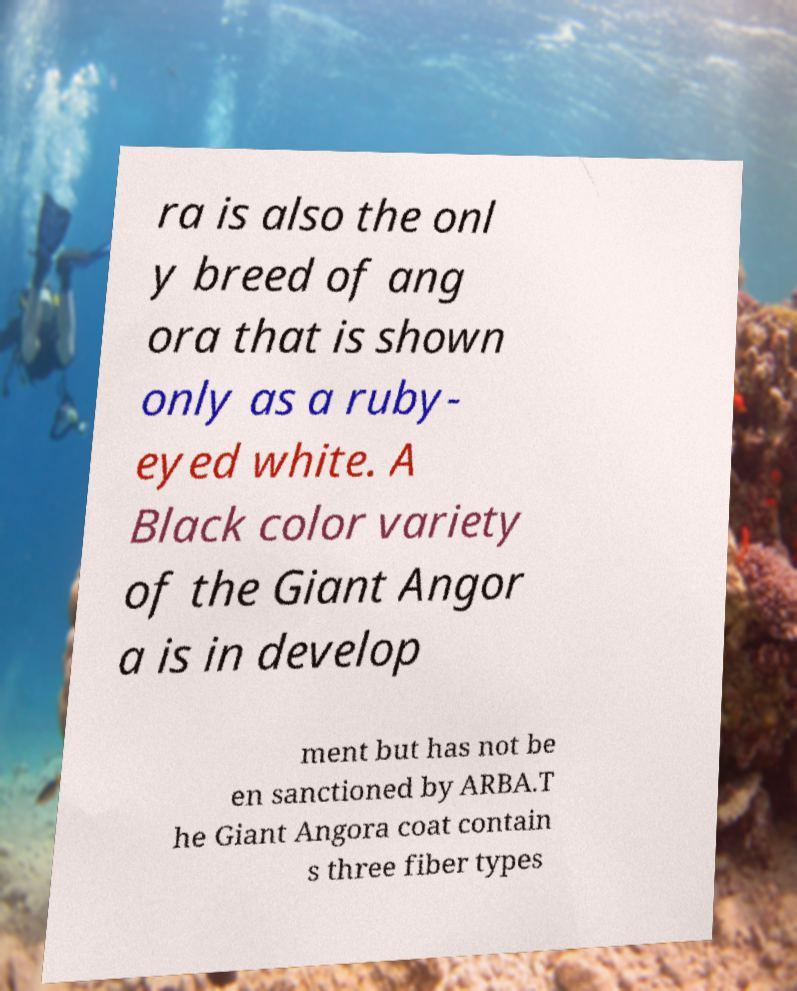What messages or text are displayed in this image? I need them in a readable, typed format. ra is also the onl y breed of ang ora that is shown only as a ruby- eyed white. A Black color variety of the Giant Angor a is in develop ment but has not be en sanctioned by ARBA.T he Giant Angora coat contain s three fiber types 